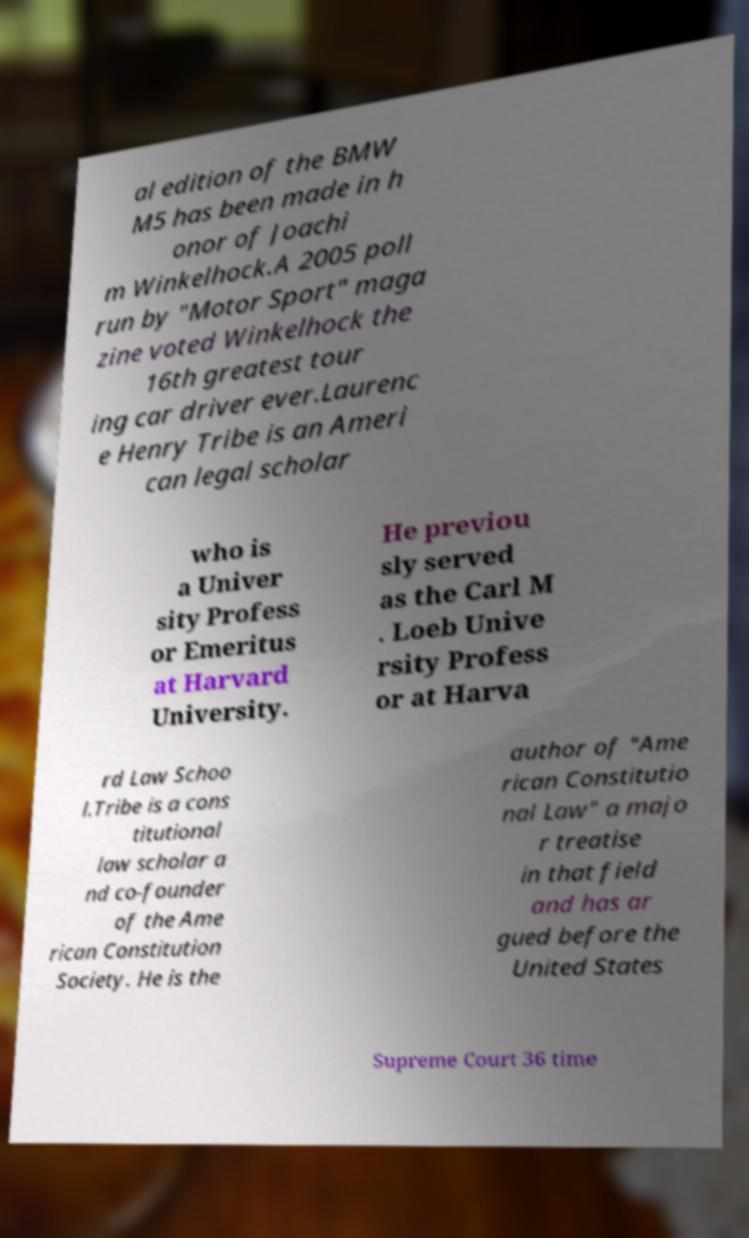For documentation purposes, I need the text within this image transcribed. Could you provide that? al edition of the BMW M5 has been made in h onor of Joachi m Winkelhock.A 2005 poll run by "Motor Sport" maga zine voted Winkelhock the 16th greatest tour ing car driver ever.Laurenc e Henry Tribe is an Ameri can legal scholar who is a Univer sity Profess or Emeritus at Harvard University. He previou sly served as the Carl M . Loeb Unive rsity Profess or at Harva rd Law Schoo l.Tribe is a cons titutional law scholar a nd co-founder of the Ame rican Constitution Society. He is the author of "Ame rican Constitutio nal Law" a majo r treatise in that field and has ar gued before the United States Supreme Court 36 time 